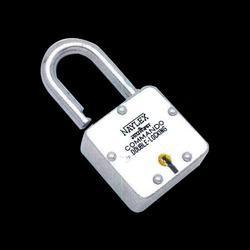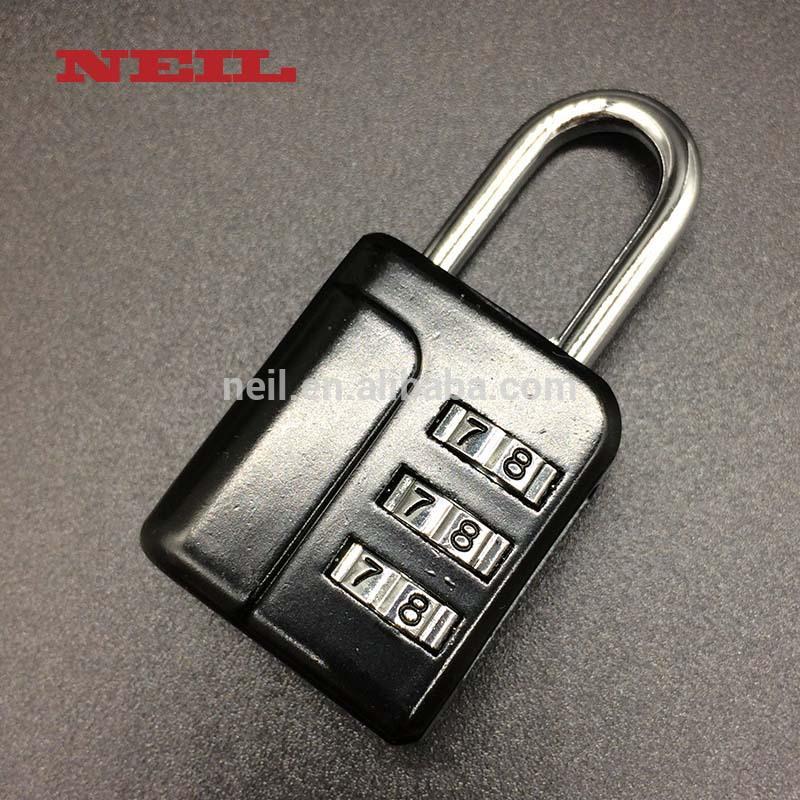The first image is the image on the left, the second image is the image on the right. For the images displayed, is the sentence "The lock in the image on the right is in the locked position." factually correct? Answer yes or no. Yes. The first image is the image on the left, the second image is the image on the right. Analyze the images presented: Is the assertion "An image of an antique-looking lock and key set includes a heart-shaped element." valid? Answer yes or no. No. 